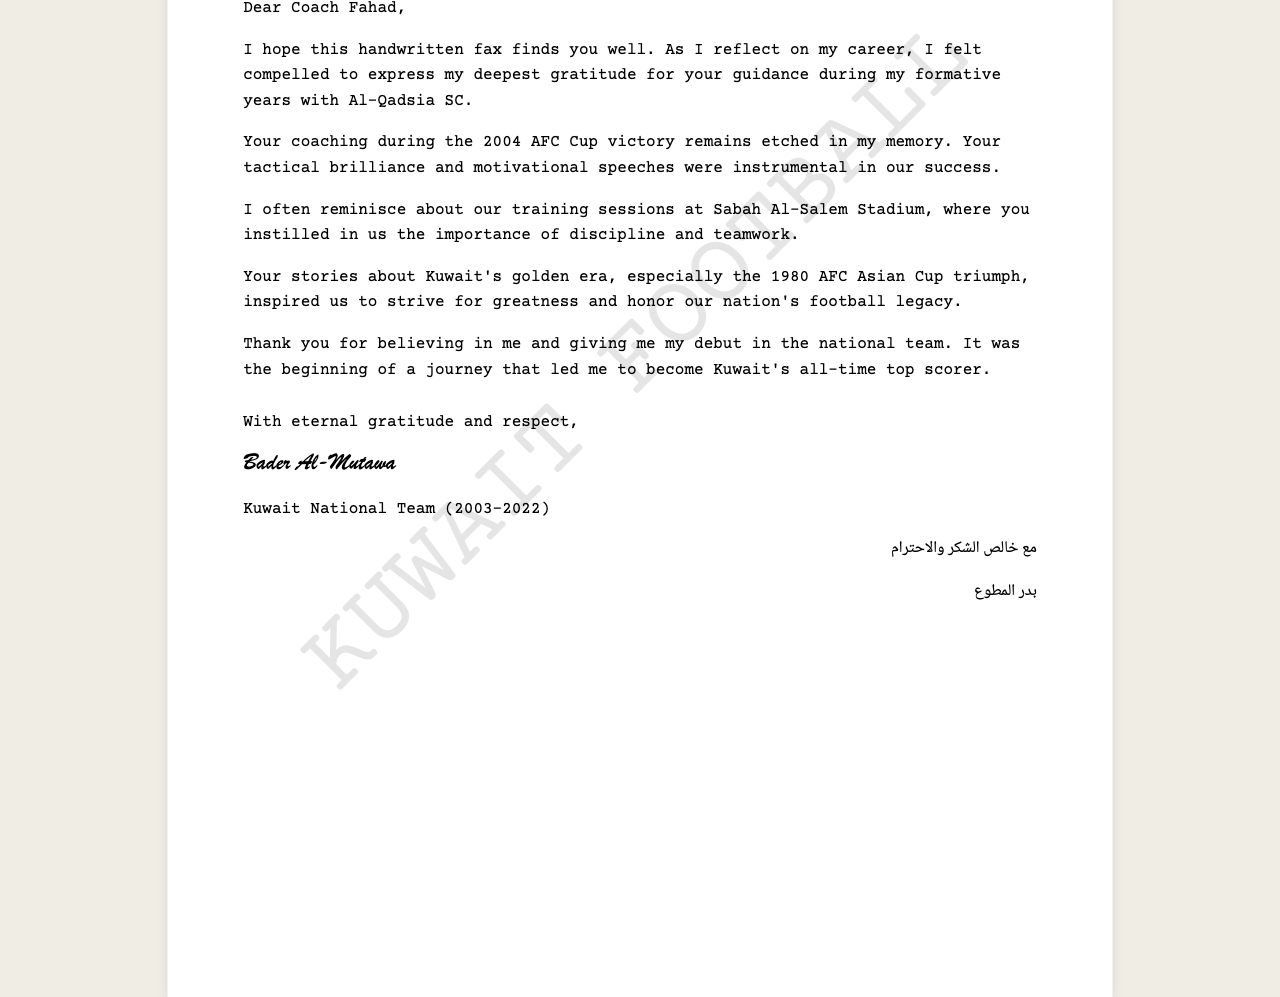What is the date of the fax? The date of the fax is explicitly mentioned in the document as "15 September 2023."
Answer: 15 September 2023 Who is the sender of the fax? The sender of the fax is indicated directly as "Bader Al-Mutawa."
Answer: Bader Al-Mutawa What club did Bader Al-Mutawa mention in the fax? The club mentioned in the fax is "Al-Qadsia SC."
Answer: Al-Qadsia SC What significant achievement is recalled in the fax? The fax refers to "the 2004 AFC Cup victory" as a significant achievement during Bader's career.
Answer: 2004 AFC Cup victory For how many years did Bader Al-Mutawa play for the Kuwait National Team? The document specifies his tenure as "2003-2022," indicating he played for 19 years.
Answer: 19 years What stadium is mentioned in the fax? The stadium referenced in the fax for training sessions is "Sabah Al-Salem Stadium."
Answer: Sabah Al-Salem Stadium What did the coach inspire Bader Al-Mutawa to honor? The coach inspired Bader to honor "our nation's football legacy."
Answer: our nation's football legacy What language is the closing of the fax written in? The closing of the fax is written in "Arabic."
Answer: Arabic What is Bader Al-Mutawa's role during his time with the national team? The fax states that he is recognized as "Kuwait's all-time top scorer."
Answer: Kuwait's all-time top scorer 